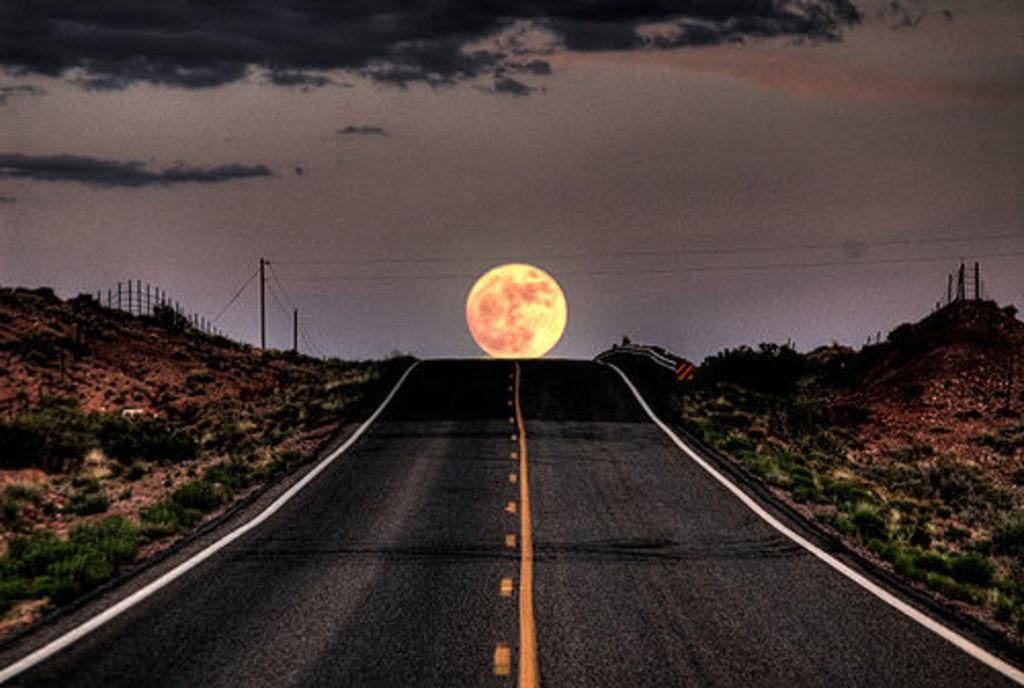Please provide a concise description of this image. This image consists of a road. In the middle, there is a sun in the sky. To the left and right, there are small plants. At the top, there are black clouds in the sky. 